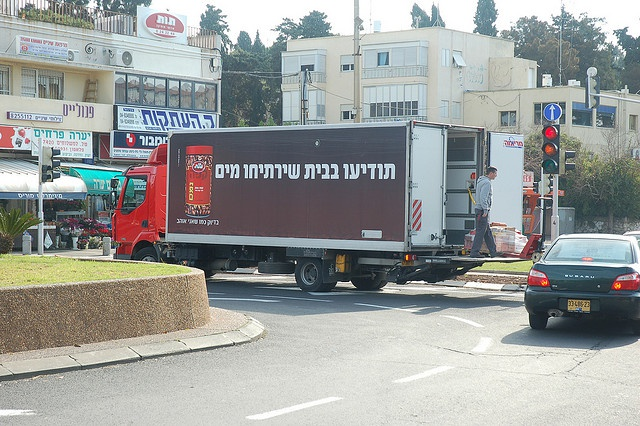Describe the objects in this image and their specific colors. I can see truck in darkgray, gray, black, and lightblue tones, car in darkgray, black, blue, white, and lightblue tones, people in darkgray, gray, and blue tones, traffic light in darkgray, gray, teal, darkblue, and black tones, and traffic light in darkgray, gray, blue, and black tones in this image. 